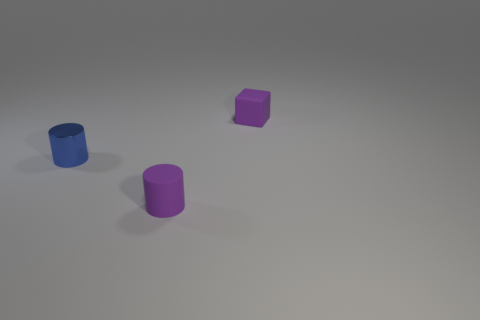Is the number of cubes greater than the number of small blue metallic blocks?
Offer a terse response. Yes. What color is the tiny shiny cylinder?
Offer a terse response. Blue. There is a tiny cylinder that is on the left side of the small purple rubber cylinder; is it the same color as the tiny rubber cylinder?
Give a very brief answer. No. There is a tiny cylinder that is the same color as the block; what material is it?
Provide a short and direct response. Rubber. What number of other small metal cylinders have the same color as the metal cylinder?
Offer a very short reply. 0. There is a tiny purple thing that is in front of the small shiny cylinder; is it the same shape as the small blue metallic object?
Provide a short and direct response. Yes. Is the number of purple rubber cylinders that are behind the blue object less than the number of small cylinders behind the block?
Your response must be concise. No. There is a purple thing left of the small purple matte block; what is its material?
Give a very brief answer. Rubber. There is a block that is the same color as the rubber cylinder; what is its size?
Your answer should be very brief. Small. Are there any purple matte objects of the same size as the rubber cylinder?
Your answer should be compact. Yes. 